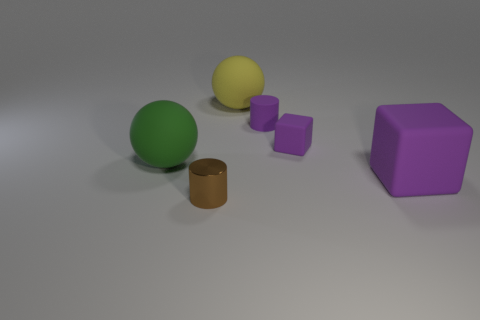Add 1 tiny rubber cylinders. How many objects exist? 7 Subtract all balls. How many objects are left? 4 Subtract all yellow objects. Subtract all big purple things. How many objects are left? 4 Add 1 shiny cylinders. How many shiny cylinders are left? 2 Add 1 small matte cylinders. How many small matte cylinders exist? 2 Subtract 0 blue balls. How many objects are left? 6 